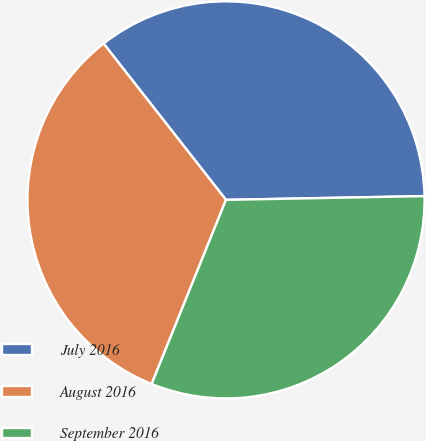Convert chart to OTSL. <chart><loc_0><loc_0><loc_500><loc_500><pie_chart><fcel>July 2016<fcel>August 2016<fcel>September 2016<nl><fcel>35.27%<fcel>33.32%<fcel>31.41%<nl></chart> 